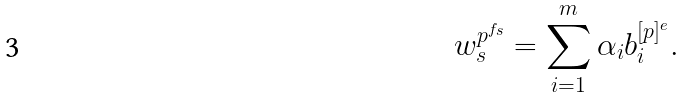<formula> <loc_0><loc_0><loc_500><loc_500>w _ { s } ^ { p ^ { f _ { s } } } = \sum _ { i = 1 } ^ { m } \alpha _ { i } b _ { i } ^ { [ p ] ^ { e } } .</formula> 